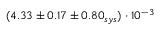<formula> <loc_0><loc_0><loc_500><loc_500>( 4 . 3 3 \pm 0 . 1 7 \pm 0 . 8 0 _ { s y s } ) \cdot 1 0 ^ { - 3 }</formula> 